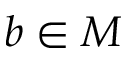Convert formula to latex. <formula><loc_0><loc_0><loc_500><loc_500>b \in M</formula> 